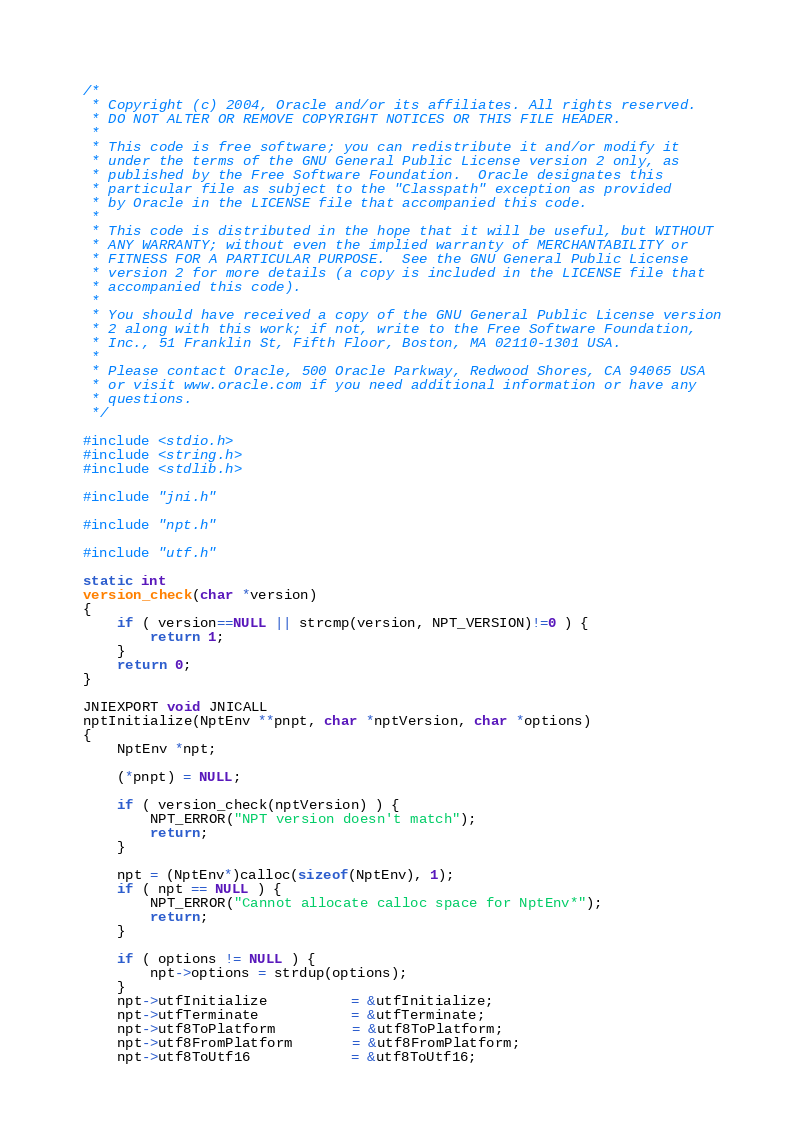<code> <loc_0><loc_0><loc_500><loc_500><_C_>/*
 * Copyright (c) 2004, Oracle and/or its affiliates. All rights reserved.
 * DO NOT ALTER OR REMOVE COPYRIGHT NOTICES OR THIS FILE HEADER.
 *
 * This code is free software; you can redistribute it and/or modify it
 * under the terms of the GNU General Public License version 2 only, as
 * published by the Free Software Foundation.  Oracle designates this
 * particular file as subject to the "Classpath" exception as provided
 * by Oracle in the LICENSE file that accompanied this code.
 *
 * This code is distributed in the hope that it will be useful, but WITHOUT
 * ANY WARRANTY; without even the implied warranty of MERCHANTABILITY or
 * FITNESS FOR A PARTICULAR PURPOSE.  See the GNU General Public License
 * version 2 for more details (a copy is included in the LICENSE file that
 * accompanied this code).
 *
 * You should have received a copy of the GNU General Public License version
 * 2 along with this work; if not, write to the Free Software Foundation,
 * Inc., 51 Franklin St, Fifth Floor, Boston, MA 02110-1301 USA.
 *
 * Please contact Oracle, 500 Oracle Parkway, Redwood Shores, CA 94065 USA
 * or visit www.oracle.com if you need additional information or have any
 * questions.
 */

#include <stdio.h>
#include <string.h>
#include <stdlib.h>

#include "jni.h"

#include "npt.h"

#include "utf.h"

static int
version_check(char *version)
{
    if ( version==NULL || strcmp(version, NPT_VERSION)!=0 ) {
        return 1;
    }
    return 0;
}

JNIEXPORT void JNICALL
nptInitialize(NptEnv **pnpt, char *nptVersion, char *options)
{
    NptEnv *npt;

    (*pnpt) = NULL;

    if ( version_check(nptVersion) ) {
        NPT_ERROR("NPT version doesn't match");
        return;
    }

    npt = (NptEnv*)calloc(sizeof(NptEnv), 1);
    if ( npt == NULL ) {
        NPT_ERROR("Cannot allocate calloc space for NptEnv*");
        return;
    }

    if ( options != NULL ) {
        npt->options = strdup(options);
    }
    npt->utfInitialize          = &utfInitialize;
    npt->utfTerminate           = &utfTerminate;
    npt->utf8ToPlatform         = &utf8ToPlatform;
    npt->utf8FromPlatform       = &utf8FromPlatform;
    npt->utf8ToUtf16            = &utf8ToUtf16;</code> 